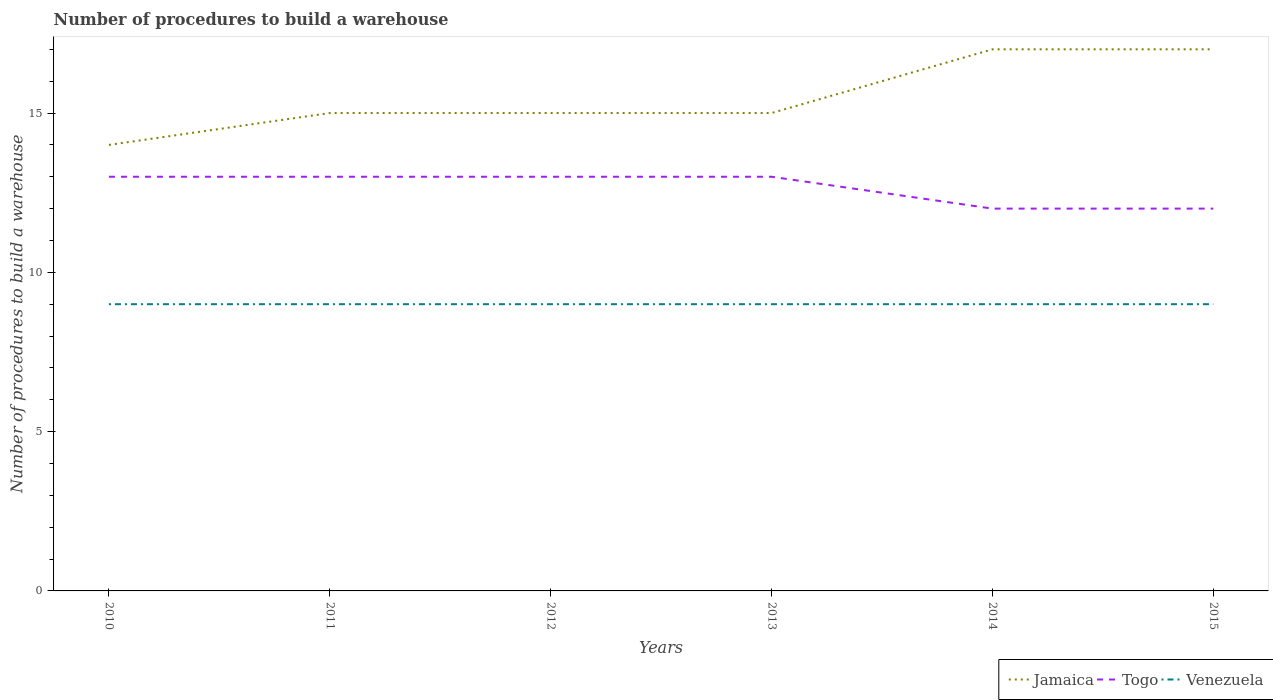How many different coloured lines are there?
Ensure brevity in your answer.  3. Does the line corresponding to Togo intersect with the line corresponding to Jamaica?
Keep it short and to the point. No. Is the number of lines equal to the number of legend labels?
Offer a very short reply. Yes. Across all years, what is the maximum number of procedures to build a warehouse in in Venezuela?
Offer a very short reply. 9. What is the total number of procedures to build a warehouse in in Jamaica in the graph?
Ensure brevity in your answer.  -3. What is the difference between the highest and the second highest number of procedures to build a warehouse in in Jamaica?
Offer a very short reply. 3. What is the difference between the highest and the lowest number of procedures to build a warehouse in in Jamaica?
Your answer should be very brief. 2. How many lines are there?
Keep it short and to the point. 3. How many years are there in the graph?
Your answer should be very brief. 6. Are the values on the major ticks of Y-axis written in scientific E-notation?
Provide a short and direct response. No. Does the graph contain grids?
Give a very brief answer. No. How are the legend labels stacked?
Provide a short and direct response. Horizontal. What is the title of the graph?
Give a very brief answer. Number of procedures to build a warehouse. Does "Korea (Republic)" appear as one of the legend labels in the graph?
Your answer should be very brief. No. What is the label or title of the Y-axis?
Give a very brief answer. Number of procedures to build a warehouse. What is the Number of procedures to build a warehouse of Togo in 2010?
Provide a short and direct response. 13. What is the Number of procedures to build a warehouse of Venezuela in 2010?
Ensure brevity in your answer.  9. What is the Number of procedures to build a warehouse of Togo in 2011?
Your answer should be very brief. 13. What is the Number of procedures to build a warehouse of Venezuela in 2011?
Your answer should be very brief. 9. What is the Number of procedures to build a warehouse in Jamaica in 2012?
Your answer should be very brief. 15. What is the Number of procedures to build a warehouse of Togo in 2012?
Your answer should be compact. 13. What is the Number of procedures to build a warehouse of Venezuela in 2012?
Your answer should be very brief. 9. What is the Number of procedures to build a warehouse of Togo in 2013?
Offer a terse response. 13. What is the Number of procedures to build a warehouse in Jamaica in 2014?
Your answer should be compact. 17. What is the Number of procedures to build a warehouse in Jamaica in 2015?
Your response must be concise. 17. Across all years, what is the maximum Number of procedures to build a warehouse in Togo?
Offer a terse response. 13. Across all years, what is the minimum Number of procedures to build a warehouse of Togo?
Give a very brief answer. 12. What is the total Number of procedures to build a warehouse of Jamaica in the graph?
Keep it short and to the point. 93. What is the total Number of procedures to build a warehouse in Togo in the graph?
Ensure brevity in your answer.  76. What is the difference between the Number of procedures to build a warehouse in Togo in 2010 and that in 2011?
Make the answer very short. 0. What is the difference between the Number of procedures to build a warehouse in Jamaica in 2010 and that in 2012?
Your response must be concise. -1. What is the difference between the Number of procedures to build a warehouse in Jamaica in 2010 and that in 2014?
Provide a short and direct response. -3. What is the difference between the Number of procedures to build a warehouse in Togo in 2010 and that in 2014?
Provide a short and direct response. 1. What is the difference between the Number of procedures to build a warehouse in Jamaica in 2010 and that in 2015?
Ensure brevity in your answer.  -3. What is the difference between the Number of procedures to build a warehouse of Venezuela in 2010 and that in 2015?
Provide a short and direct response. 0. What is the difference between the Number of procedures to build a warehouse of Jamaica in 2011 and that in 2012?
Offer a terse response. 0. What is the difference between the Number of procedures to build a warehouse in Togo in 2011 and that in 2012?
Offer a terse response. 0. What is the difference between the Number of procedures to build a warehouse in Venezuela in 2011 and that in 2012?
Your answer should be very brief. 0. What is the difference between the Number of procedures to build a warehouse of Jamaica in 2011 and that in 2013?
Your response must be concise. 0. What is the difference between the Number of procedures to build a warehouse in Venezuela in 2011 and that in 2013?
Offer a terse response. 0. What is the difference between the Number of procedures to build a warehouse of Jamaica in 2011 and that in 2014?
Your answer should be compact. -2. What is the difference between the Number of procedures to build a warehouse in Togo in 2011 and that in 2014?
Your answer should be compact. 1. What is the difference between the Number of procedures to build a warehouse of Jamaica in 2011 and that in 2015?
Offer a very short reply. -2. What is the difference between the Number of procedures to build a warehouse in Venezuela in 2011 and that in 2015?
Make the answer very short. 0. What is the difference between the Number of procedures to build a warehouse in Togo in 2012 and that in 2013?
Give a very brief answer. 0. What is the difference between the Number of procedures to build a warehouse in Venezuela in 2012 and that in 2013?
Your response must be concise. 0. What is the difference between the Number of procedures to build a warehouse in Togo in 2012 and that in 2014?
Make the answer very short. 1. What is the difference between the Number of procedures to build a warehouse in Jamaica in 2012 and that in 2015?
Make the answer very short. -2. What is the difference between the Number of procedures to build a warehouse in Jamaica in 2013 and that in 2014?
Offer a very short reply. -2. What is the difference between the Number of procedures to build a warehouse of Jamaica in 2013 and that in 2015?
Keep it short and to the point. -2. What is the difference between the Number of procedures to build a warehouse of Togo in 2014 and that in 2015?
Provide a succinct answer. 0. What is the difference between the Number of procedures to build a warehouse in Jamaica in 2010 and the Number of procedures to build a warehouse in Togo in 2011?
Provide a short and direct response. 1. What is the difference between the Number of procedures to build a warehouse of Jamaica in 2010 and the Number of procedures to build a warehouse of Venezuela in 2013?
Your response must be concise. 5. What is the difference between the Number of procedures to build a warehouse in Jamaica in 2010 and the Number of procedures to build a warehouse in Togo in 2014?
Provide a short and direct response. 2. What is the difference between the Number of procedures to build a warehouse in Jamaica in 2010 and the Number of procedures to build a warehouse in Venezuela in 2014?
Offer a very short reply. 5. What is the difference between the Number of procedures to build a warehouse in Jamaica in 2010 and the Number of procedures to build a warehouse in Togo in 2015?
Keep it short and to the point. 2. What is the difference between the Number of procedures to build a warehouse of Jamaica in 2011 and the Number of procedures to build a warehouse of Venezuela in 2013?
Provide a short and direct response. 6. What is the difference between the Number of procedures to build a warehouse of Togo in 2011 and the Number of procedures to build a warehouse of Venezuela in 2013?
Offer a very short reply. 4. What is the difference between the Number of procedures to build a warehouse in Jamaica in 2011 and the Number of procedures to build a warehouse in Togo in 2014?
Give a very brief answer. 3. What is the difference between the Number of procedures to build a warehouse in Jamaica in 2011 and the Number of procedures to build a warehouse in Venezuela in 2014?
Ensure brevity in your answer.  6. What is the difference between the Number of procedures to build a warehouse of Jamaica in 2011 and the Number of procedures to build a warehouse of Togo in 2015?
Keep it short and to the point. 3. What is the difference between the Number of procedures to build a warehouse of Togo in 2011 and the Number of procedures to build a warehouse of Venezuela in 2015?
Provide a succinct answer. 4. What is the difference between the Number of procedures to build a warehouse of Jamaica in 2012 and the Number of procedures to build a warehouse of Venezuela in 2013?
Make the answer very short. 6. What is the difference between the Number of procedures to build a warehouse of Togo in 2012 and the Number of procedures to build a warehouse of Venezuela in 2013?
Ensure brevity in your answer.  4. What is the difference between the Number of procedures to build a warehouse of Jamaica in 2012 and the Number of procedures to build a warehouse of Venezuela in 2014?
Provide a short and direct response. 6. What is the difference between the Number of procedures to build a warehouse in Jamaica in 2012 and the Number of procedures to build a warehouse in Venezuela in 2015?
Your response must be concise. 6. What is the difference between the Number of procedures to build a warehouse in Togo in 2012 and the Number of procedures to build a warehouse in Venezuela in 2015?
Your answer should be very brief. 4. What is the difference between the Number of procedures to build a warehouse of Jamaica in 2013 and the Number of procedures to build a warehouse of Togo in 2014?
Your response must be concise. 3. What is the difference between the Number of procedures to build a warehouse in Jamaica in 2013 and the Number of procedures to build a warehouse in Venezuela in 2014?
Keep it short and to the point. 6. What is the difference between the Number of procedures to build a warehouse of Togo in 2013 and the Number of procedures to build a warehouse of Venezuela in 2015?
Your answer should be very brief. 4. What is the difference between the Number of procedures to build a warehouse in Jamaica in 2014 and the Number of procedures to build a warehouse in Togo in 2015?
Give a very brief answer. 5. What is the difference between the Number of procedures to build a warehouse of Jamaica in 2014 and the Number of procedures to build a warehouse of Venezuela in 2015?
Your answer should be compact. 8. What is the difference between the Number of procedures to build a warehouse of Togo in 2014 and the Number of procedures to build a warehouse of Venezuela in 2015?
Your answer should be very brief. 3. What is the average Number of procedures to build a warehouse of Togo per year?
Provide a succinct answer. 12.67. In the year 2010, what is the difference between the Number of procedures to build a warehouse in Jamaica and Number of procedures to build a warehouse in Togo?
Provide a succinct answer. 1. In the year 2010, what is the difference between the Number of procedures to build a warehouse of Jamaica and Number of procedures to build a warehouse of Venezuela?
Make the answer very short. 5. In the year 2011, what is the difference between the Number of procedures to build a warehouse in Jamaica and Number of procedures to build a warehouse in Togo?
Offer a very short reply. 2. In the year 2011, what is the difference between the Number of procedures to build a warehouse of Jamaica and Number of procedures to build a warehouse of Venezuela?
Your answer should be compact. 6. In the year 2011, what is the difference between the Number of procedures to build a warehouse in Togo and Number of procedures to build a warehouse in Venezuela?
Your answer should be compact. 4. In the year 2012, what is the difference between the Number of procedures to build a warehouse in Togo and Number of procedures to build a warehouse in Venezuela?
Offer a very short reply. 4. In the year 2013, what is the difference between the Number of procedures to build a warehouse in Jamaica and Number of procedures to build a warehouse in Venezuela?
Keep it short and to the point. 6. In the year 2014, what is the difference between the Number of procedures to build a warehouse of Jamaica and Number of procedures to build a warehouse of Togo?
Provide a succinct answer. 5. In the year 2014, what is the difference between the Number of procedures to build a warehouse in Togo and Number of procedures to build a warehouse in Venezuela?
Give a very brief answer. 3. In the year 2015, what is the difference between the Number of procedures to build a warehouse in Jamaica and Number of procedures to build a warehouse in Venezuela?
Keep it short and to the point. 8. What is the ratio of the Number of procedures to build a warehouse of Togo in 2010 to that in 2012?
Provide a succinct answer. 1. What is the ratio of the Number of procedures to build a warehouse of Venezuela in 2010 to that in 2012?
Offer a terse response. 1. What is the ratio of the Number of procedures to build a warehouse in Venezuela in 2010 to that in 2013?
Provide a short and direct response. 1. What is the ratio of the Number of procedures to build a warehouse in Jamaica in 2010 to that in 2014?
Ensure brevity in your answer.  0.82. What is the ratio of the Number of procedures to build a warehouse of Togo in 2010 to that in 2014?
Offer a very short reply. 1.08. What is the ratio of the Number of procedures to build a warehouse of Jamaica in 2010 to that in 2015?
Give a very brief answer. 0.82. What is the ratio of the Number of procedures to build a warehouse of Venezuela in 2010 to that in 2015?
Your answer should be compact. 1. What is the ratio of the Number of procedures to build a warehouse of Jamaica in 2011 to that in 2012?
Provide a succinct answer. 1. What is the ratio of the Number of procedures to build a warehouse in Togo in 2011 to that in 2012?
Your response must be concise. 1. What is the ratio of the Number of procedures to build a warehouse of Togo in 2011 to that in 2013?
Offer a very short reply. 1. What is the ratio of the Number of procedures to build a warehouse of Venezuela in 2011 to that in 2013?
Your answer should be compact. 1. What is the ratio of the Number of procedures to build a warehouse of Jamaica in 2011 to that in 2014?
Keep it short and to the point. 0.88. What is the ratio of the Number of procedures to build a warehouse of Togo in 2011 to that in 2014?
Make the answer very short. 1.08. What is the ratio of the Number of procedures to build a warehouse of Venezuela in 2011 to that in 2014?
Your answer should be compact. 1. What is the ratio of the Number of procedures to build a warehouse of Jamaica in 2011 to that in 2015?
Your answer should be compact. 0.88. What is the ratio of the Number of procedures to build a warehouse in Togo in 2011 to that in 2015?
Your answer should be very brief. 1.08. What is the ratio of the Number of procedures to build a warehouse of Jamaica in 2012 to that in 2013?
Keep it short and to the point. 1. What is the ratio of the Number of procedures to build a warehouse in Jamaica in 2012 to that in 2014?
Provide a succinct answer. 0.88. What is the ratio of the Number of procedures to build a warehouse of Togo in 2012 to that in 2014?
Provide a short and direct response. 1.08. What is the ratio of the Number of procedures to build a warehouse of Jamaica in 2012 to that in 2015?
Provide a short and direct response. 0.88. What is the ratio of the Number of procedures to build a warehouse in Togo in 2012 to that in 2015?
Make the answer very short. 1.08. What is the ratio of the Number of procedures to build a warehouse of Venezuela in 2012 to that in 2015?
Provide a short and direct response. 1. What is the ratio of the Number of procedures to build a warehouse of Jamaica in 2013 to that in 2014?
Keep it short and to the point. 0.88. What is the ratio of the Number of procedures to build a warehouse of Togo in 2013 to that in 2014?
Ensure brevity in your answer.  1.08. What is the ratio of the Number of procedures to build a warehouse of Venezuela in 2013 to that in 2014?
Make the answer very short. 1. What is the ratio of the Number of procedures to build a warehouse in Jamaica in 2013 to that in 2015?
Offer a very short reply. 0.88. What is the ratio of the Number of procedures to build a warehouse in Togo in 2013 to that in 2015?
Give a very brief answer. 1.08. What is the ratio of the Number of procedures to build a warehouse in Venezuela in 2014 to that in 2015?
Provide a succinct answer. 1. What is the difference between the highest and the second highest Number of procedures to build a warehouse in Jamaica?
Provide a short and direct response. 0. What is the difference between the highest and the second highest Number of procedures to build a warehouse in Venezuela?
Provide a succinct answer. 0. What is the difference between the highest and the lowest Number of procedures to build a warehouse of Jamaica?
Provide a short and direct response. 3. 